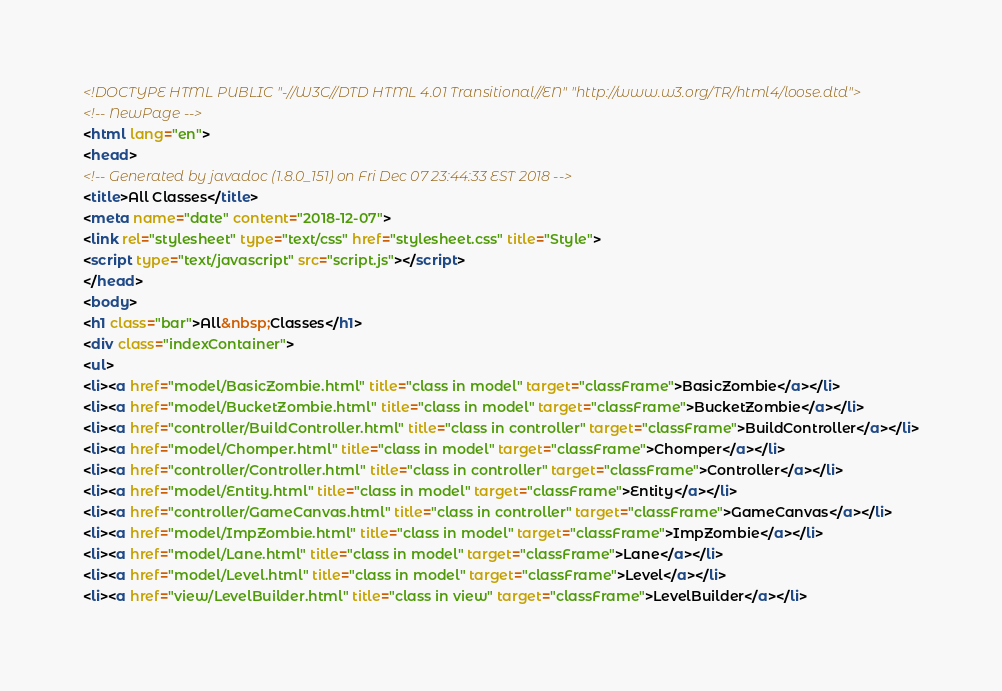Convert code to text. <code><loc_0><loc_0><loc_500><loc_500><_HTML_><!DOCTYPE HTML PUBLIC "-//W3C//DTD HTML 4.01 Transitional//EN" "http://www.w3.org/TR/html4/loose.dtd">
<!-- NewPage -->
<html lang="en">
<head>
<!-- Generated by javadoc (1.8.0_151) on Fri Dec 07 23:44:33 EST 2018 -->
<title>All Classes</title>
<meta name="date" content="2018-12-07">
<link rel="stylesheet" type="text/css" href="stylesheet.css" title="Style">
<script type="text/javascript" src="script.js"></script>
</head>
<body>
<h1 class="bar">All&nbsp;Classes</h1>
<div class="indexContainer">
<ul>
<li><a href="model/BasicZombie.html" title="class in model" target="classFrame">BasicZombie</a></li>
<li><a href="model/BucketZombie.html" title="class in model" target="classFrame">BucketZombie</a></li>
<li><a href="controller/BuildController.html" title="class in controller" target="classFrame">BuildController</a></li>
<li><a href="model/Chomper.html" title="class in model" target="classFrame">Chomper</a></li>
<li><a href="controller/Controller.html" title="class in controller" target="classFrame">Controller</a></li>
<li><a href="model/Entity.html" title="class in model" target="classFrame">Entity</a></li>
<li><a href="controller/GameCanvas.html" title="class in controller" target="classFrame">GameCanvas</a></li>
<li><a href="model/ImpZombie.html" title="class in model" target="classFrame">ImpZombie</a></li>
<li><a href="model/Lane.html" title="class in model" target="classFrame">Lane</a></li>
<li><a href="model/Level.html" title="class in model" target="classFrame">Level</a></li>
<li><a href="view/LevelBuilder.html" title="class in view" target="classFrame">LevelBuilder</a></li></code> 